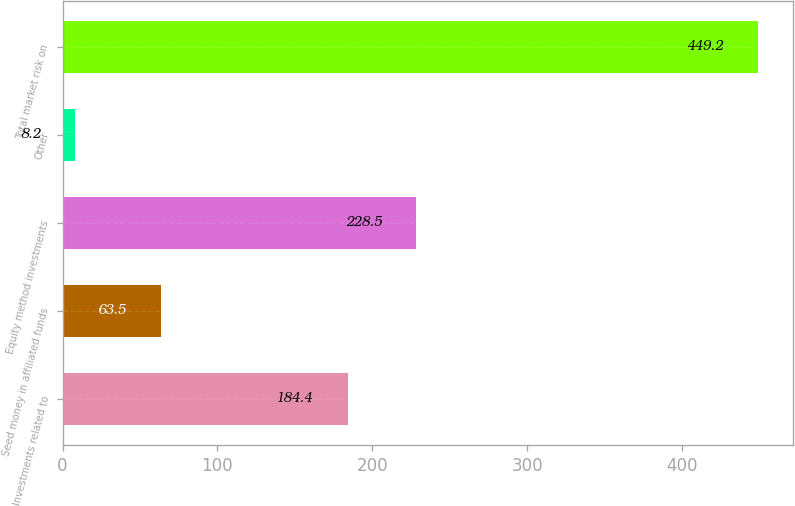Convert chart to OTSL. <chart><loc_0><loc_0><loc_500><loc_500><bar_chart><fcel>Investments related to<fcel>Seed money in affiliated funds<fcel>Equity method investments<fcel>Other<fcel>Total market risk on<nl><fcel>184.4<fcel>63.5<fcel>228.5<fcel>8.2<fcel>449.2<nl></chart> 